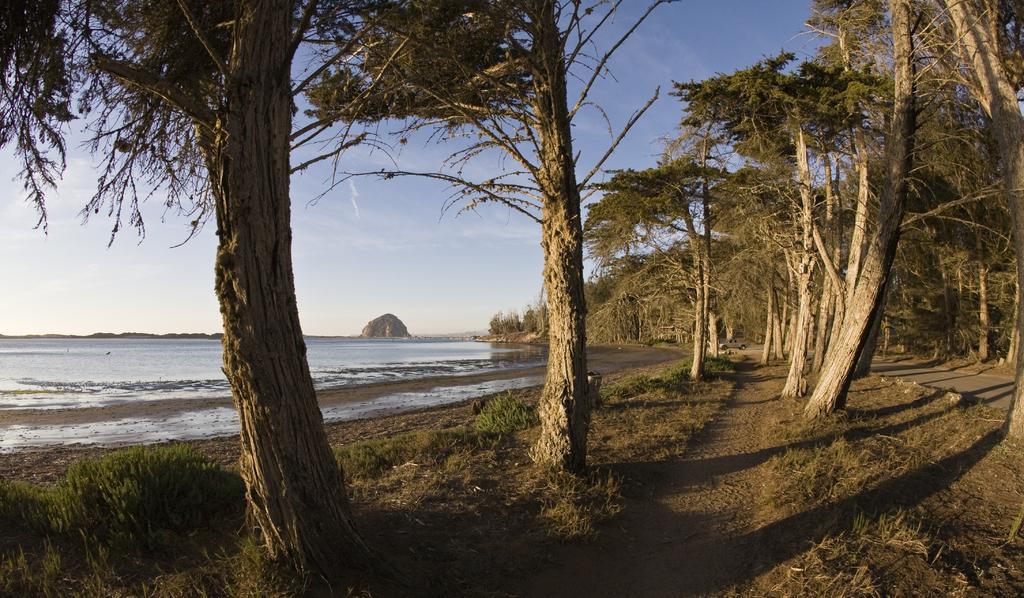Can you describe this image briefly? In this image in front there are trees. On the right side of the image there is a road. On the left side of the image there is water. In the background of the image there are rocks and sky. 